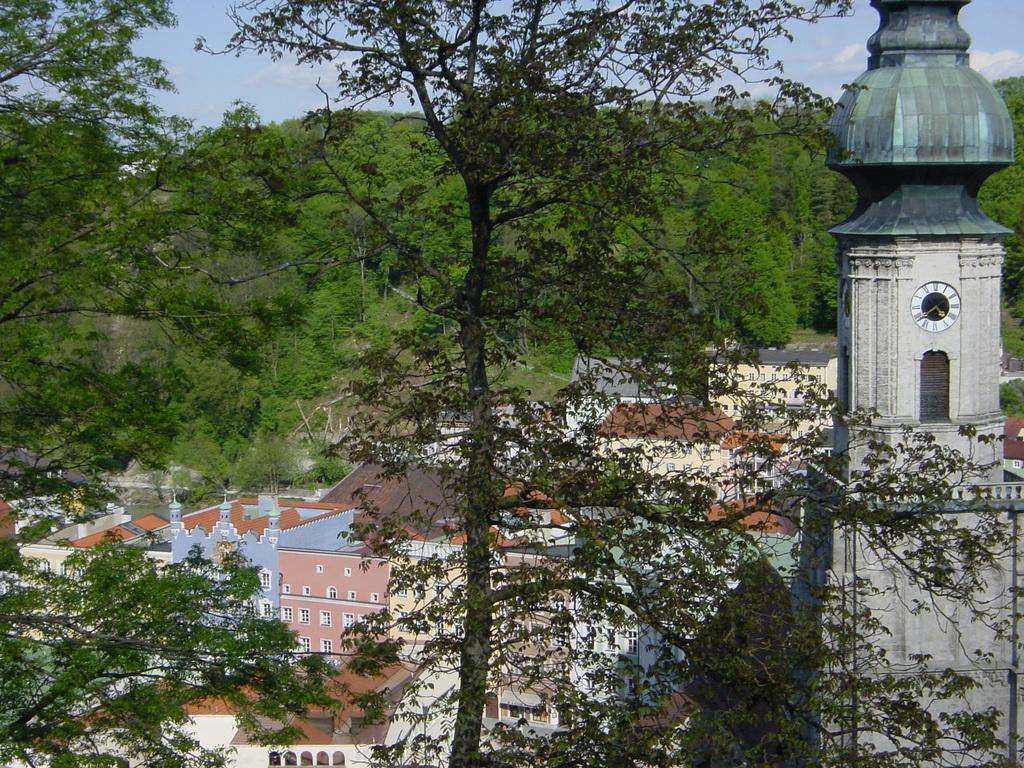What structure is located on the right side of the image? There is a clock tower on the right side of the image. What can be seen in the background of the image? There are houses and trees in the background of the image. What is visible in the sky in the background of the image? There are clouds in the sky in the background of the image. What type of pancake is being served at the vegetable stand in the image? There is no pancake or vegetable stand present in the image. 